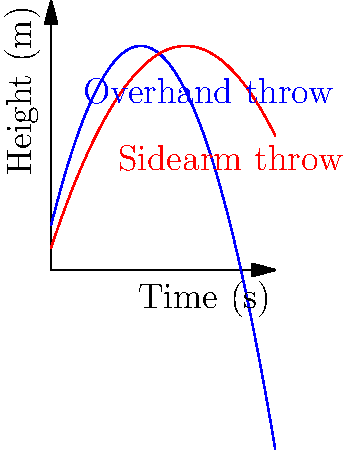As a relaxed athlete, you're experimenting with different throwing techniques. The graph shows the trajectories of a ball thrown using overhand and sidearm techniques. At what time does the ball reach its maximum height for each throw, and what's the difference in maximum heights between the two techniques? Let's approach this step-by-step:

1) For each trajectory, the maximum height occurs at the vertex of the parabola.

2) For a quadratic function in the form $f(x) = -ax^2 + bx + c$, the x-coordinate of the vertex is given by $x = \frac{b}{2a}$.

3) For the overhand throw (blue curve):
   $f(x) = -x^2 + 4x + 1$
   $a = 1$, $b = 4$
   Time of max height: $x = \frac{4}{2(1)} = 2$ seconds

4) For the sidearm throw (red curve):
   $f(x) = -0.5x^2 + 3x + 0.5$
   $a = 0.5$, $b = 3$
   Time of max height: $x = \frac{3}{2(0.5)} = 3$ seconds

5) To find the maximum heights, we substitute these x-values into their respective equations:

   Overhand: $f(2) = -(2)^2 + 4(2) + 1 = 5$ meters
   Sidearm: $f(3) = -0.5(3)^2 + 3(3) + 0.5 = 3.25$ meters

6) The difference in maximum heights:
   $5 - 3.25 = 1.75$ meters
Answer: Overhand: 2s, 5m; Sidearm: 3s, 3.25m; Difference: 1.75m 